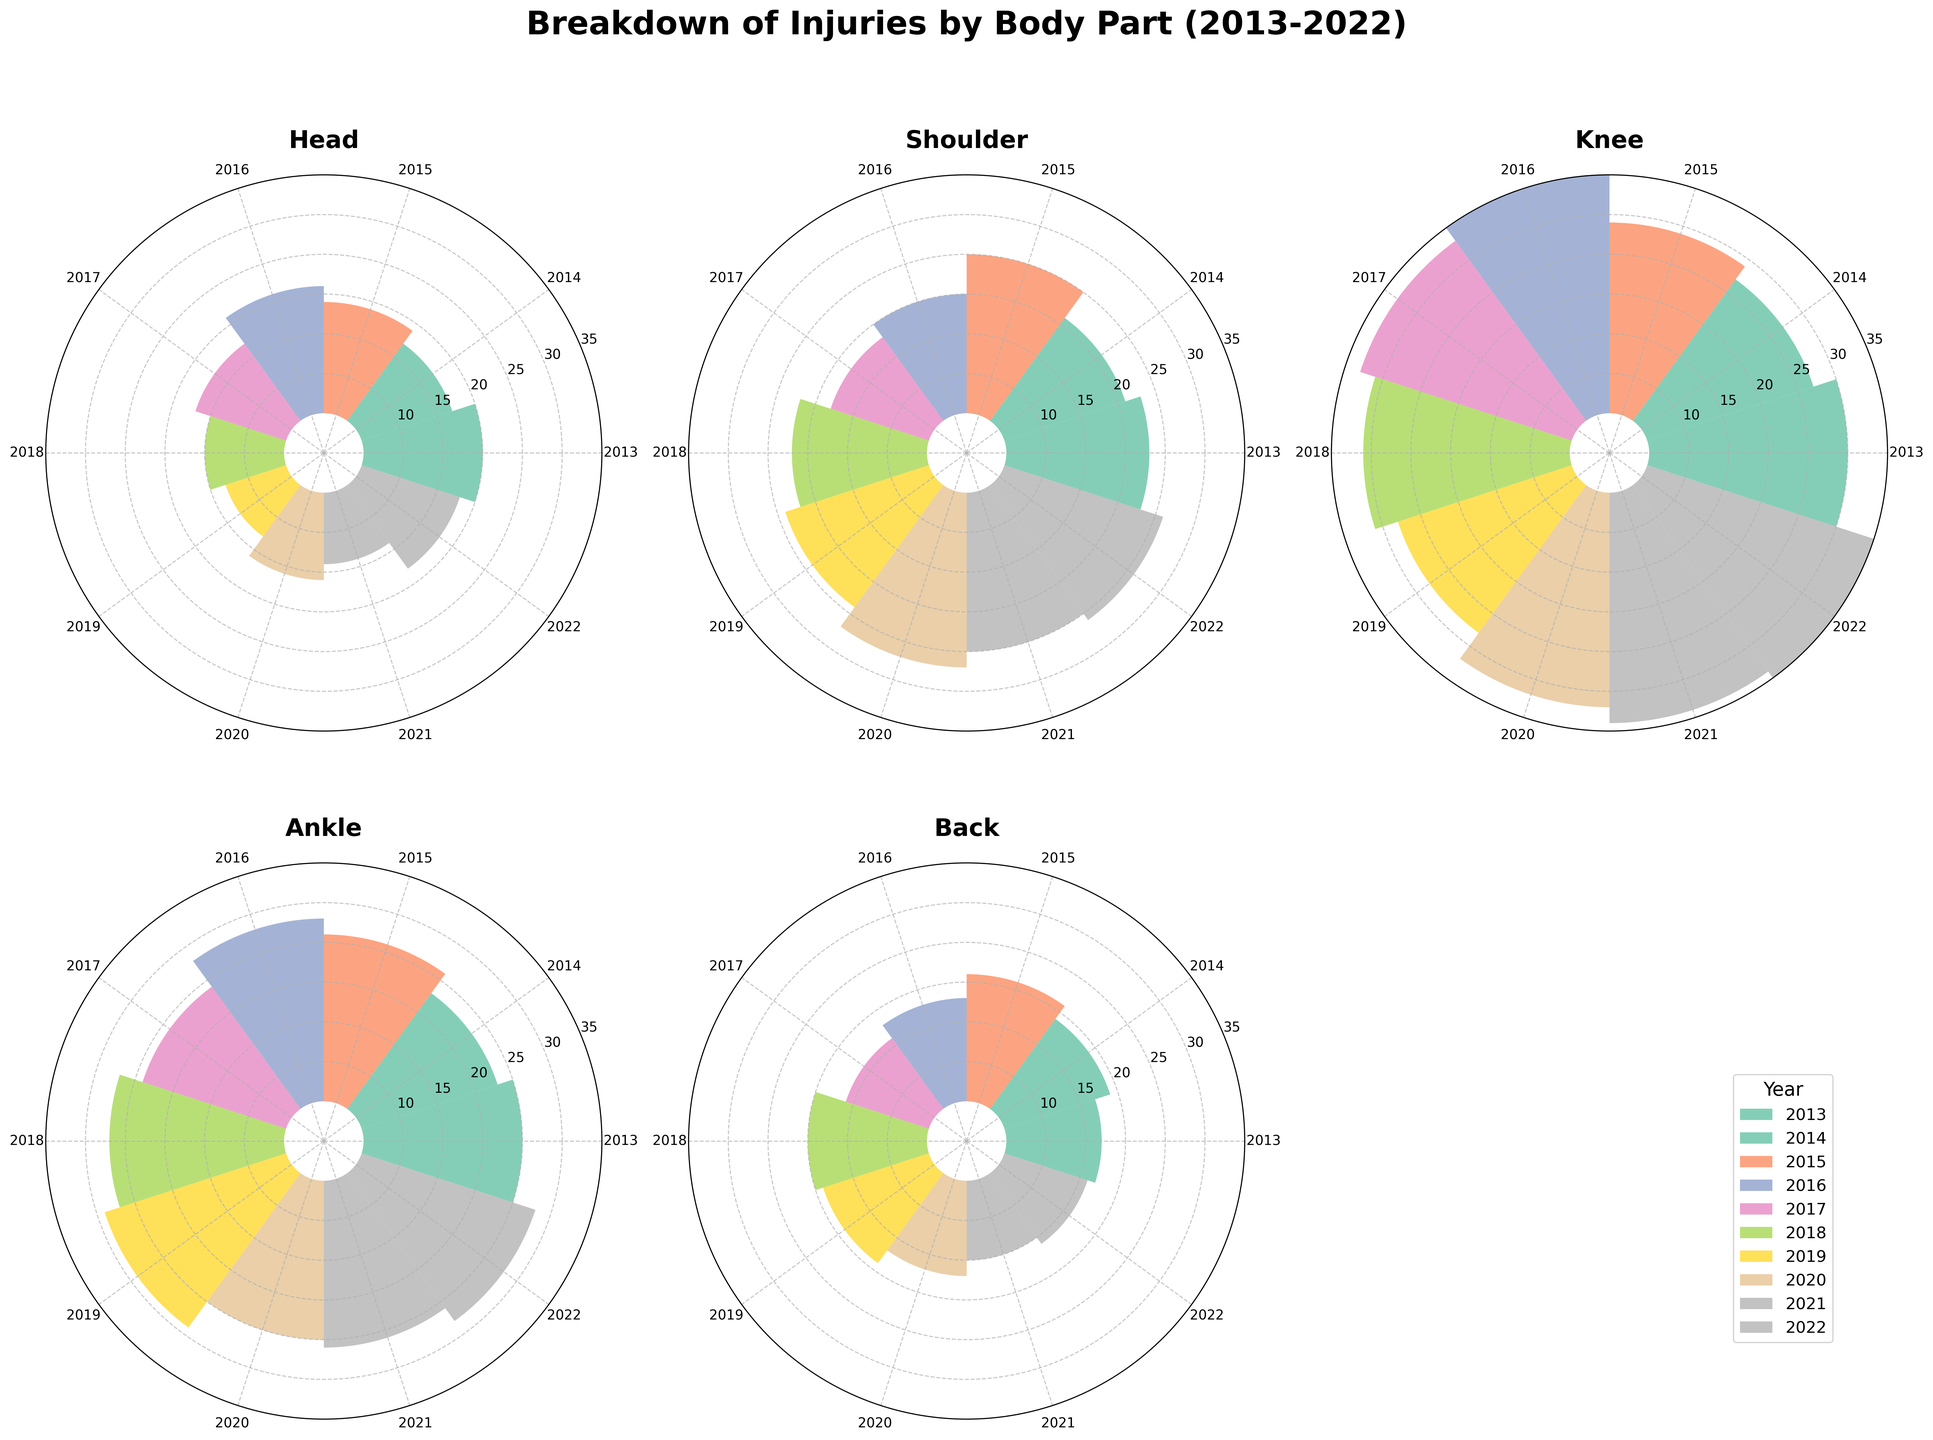What is the title of the polar chart figure? The title is prominently displayed at the top of the figure. It is in bold font and clearly indicates the purpose of the chart.
Answer: Breakdown of Injuries by Body Part (2013-2022) Which body part had the highest frequency of injuries in the year 2022? By looking at the frequency bars for the year 2022 in each subplot, you can identify the one with the highest value.
Answer: Knee How does the frequency of head injuries in 2013 compare to 2022? The frequency in 2013 is 15 and in 2022 it is 13, which are directly from the polar chart's bars for these years under the head injury subplot. The difference is 2.
Answer: 2 less Which year had the peak frequency of knee injuries? By observing the knee injury subplot, the peak bar can be identified. It corresponds to the radial length of the bar.
Answer: 2022 How many body parts are analyzed in this figure? The figure contains subplots for different body parts; counting these subplots will give the number.
Answer: 5 What trend can be observed for back injuries over the 10 years? Observing the bars for back injuries across all years, notice any upward, downward, or stable patterns. The general direction is important.
Answer: Slightly downward trend Which body part had the most stable frequency of injuries over the years? Stability can be analyzed by observing the variation (or lack thereof) in the height of the bars over the years for each body part.
Answer: Back Which year had the lowest frequency of ankle injuries, and what was it? Identifying the lowest bar in the ankle subplot and noting its length and corresponding year will give this information.
Answer: 2014, 18 What was the most common injury in 2016 and how frequent was it? By looking at the length of bars in each subplot for the year 2016, we can identify the longest bar.
Answer: Knee, 30 How does the injury frequency of shoulders in 2020 compare to that in 2021? Compare the lengths of the bars for shoulders in 2020 and 2021 to assess the difference. In 2020 it is 22, and in 2021 it is 20. The difference is 2.
Answer: 2 less 